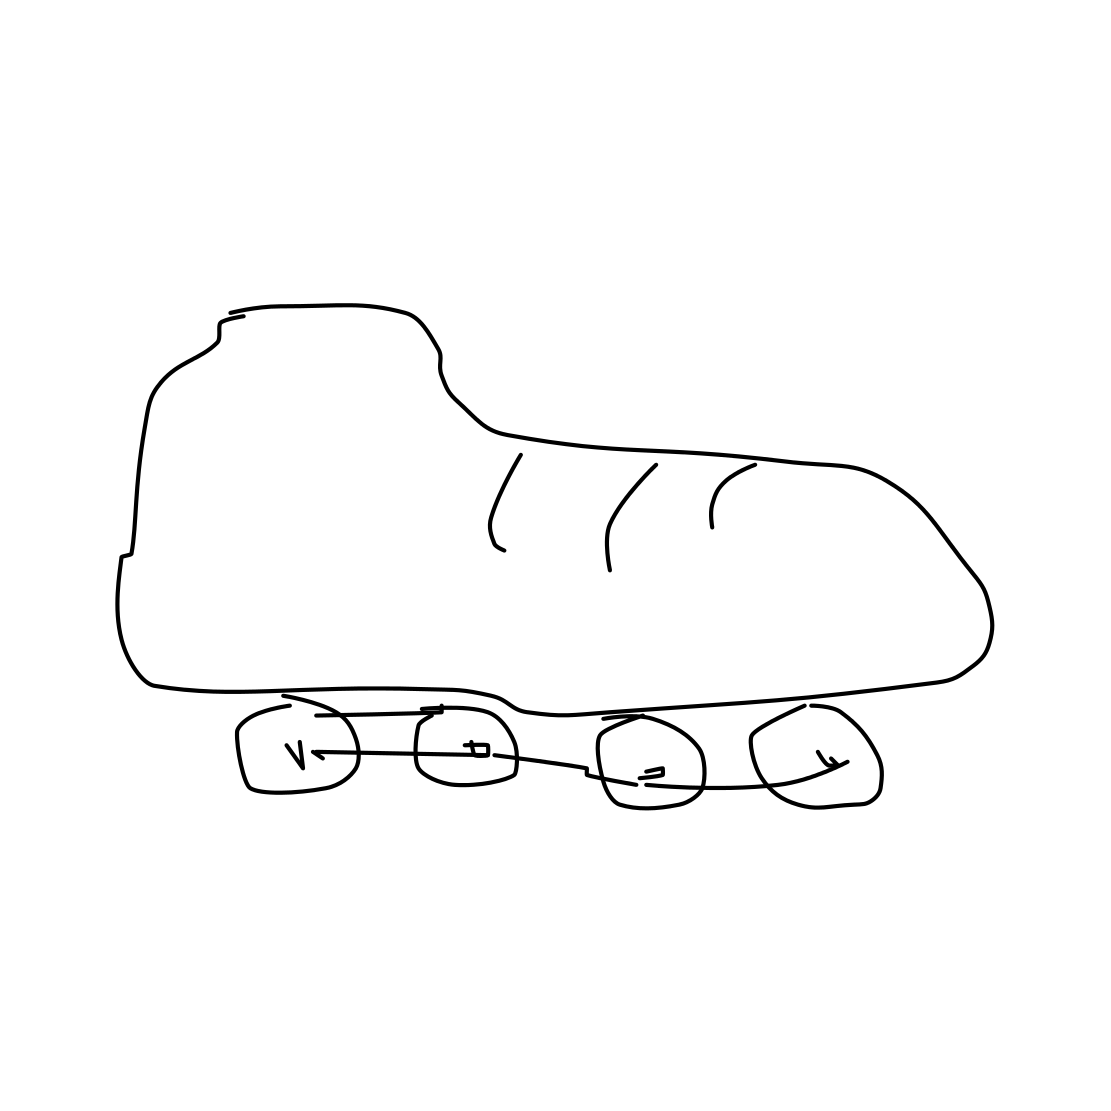How might these rollerblades be used in real life, based on their design? These rollerblades appear to be designed for casual or recreational use, evident from their basic, no-frills design. They're suitable for general skating activities, offering functionality without complex features. 